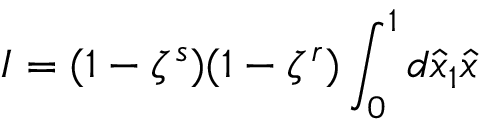<formula> <loc_0><loc_0><loc_500><loc_500>I = ( 1 - \zeta ^ { s } ) ( 1 - \zeta ^ { r } ) \int _ { 0 } ^ { 1 } d \hat { x } _ { 1 } \hat { x }</formula> 